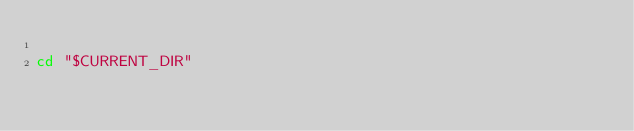Convert code to text. <code><loc_0><loc_0><loc_500><loc_500><_Bash_>
cd "$CURRENT_DIR"
</code> 